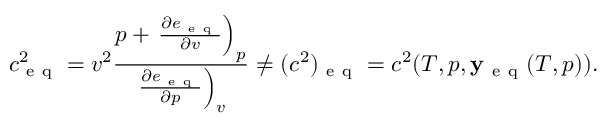Convert formula to latex. <formula><loc_0><loc_0><loc_500><loc_500>c _ { e q } ^ { 2 } = v ^ { 2 } \frac { p + \frac { \partial e _ { e q } } { \partial v } \right ) _ { p } } { \frac { \partial e _ { e q } } { \partial p } \right ) _ { v } } \ne ( c ^ { 2 } ) _ { e q } = c ^ { 2 } ( T , p , y _ { e q } ( T , p ) ) .</formula> 